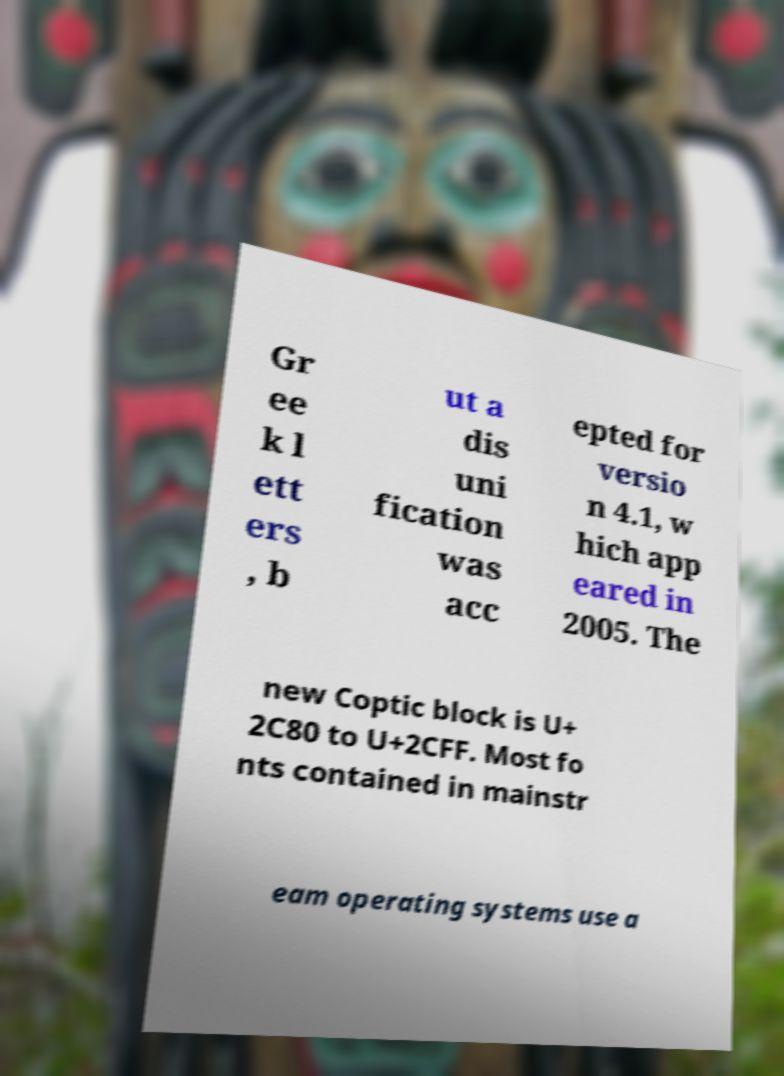Can you accurately transcribe the text from the provided image for me? Gr ee k l ett ers , b ut a dis uni fication was acc epted for versio n 4.1, w hich app eared in 2005. The new Coptic block is U+ 2C80 to U+2CFF. Most fo nts contained in mainstr eam operating systems use a 